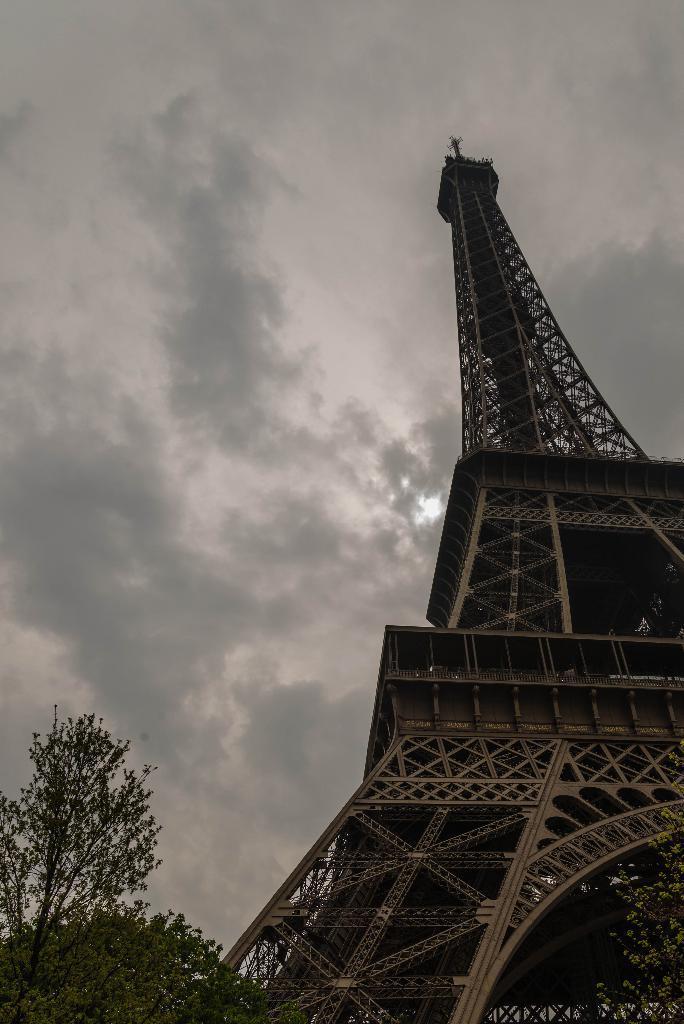In one or two sentences, can you explain what this image depicts? There is a tree and tower in the foreground area of the image and the sky in the background. 